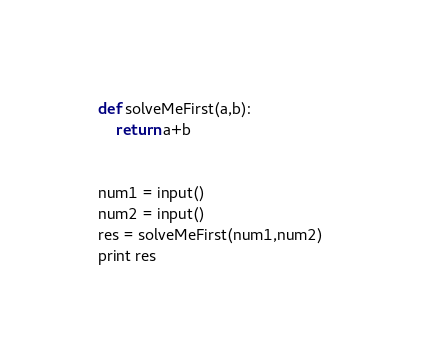Convert code to text. <code><loc_0><loc_0><loc_500><loc_500><_Python_>def solveMeFirst(a,b):
    return a+b


num1 = input()
num2 = input()
res = solveMeFirst(num1,num2)
print res
</code> 